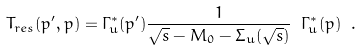Convert formula to latex. <formula><loc_0><loc_0><loc_500><loc_500>T _ { r e s } ( p ^ { \prime } , p ) = \Gamma ^ { * } _ { u } ( p ^ { \prime } ) \frac { 1 } { \sqrt { s } - M _ { 0 } - \Sigma _ { u } ( \sqrt { s } ) } \ \Gamma ^ { * } _ { u } ( p ) \ .</formula> 